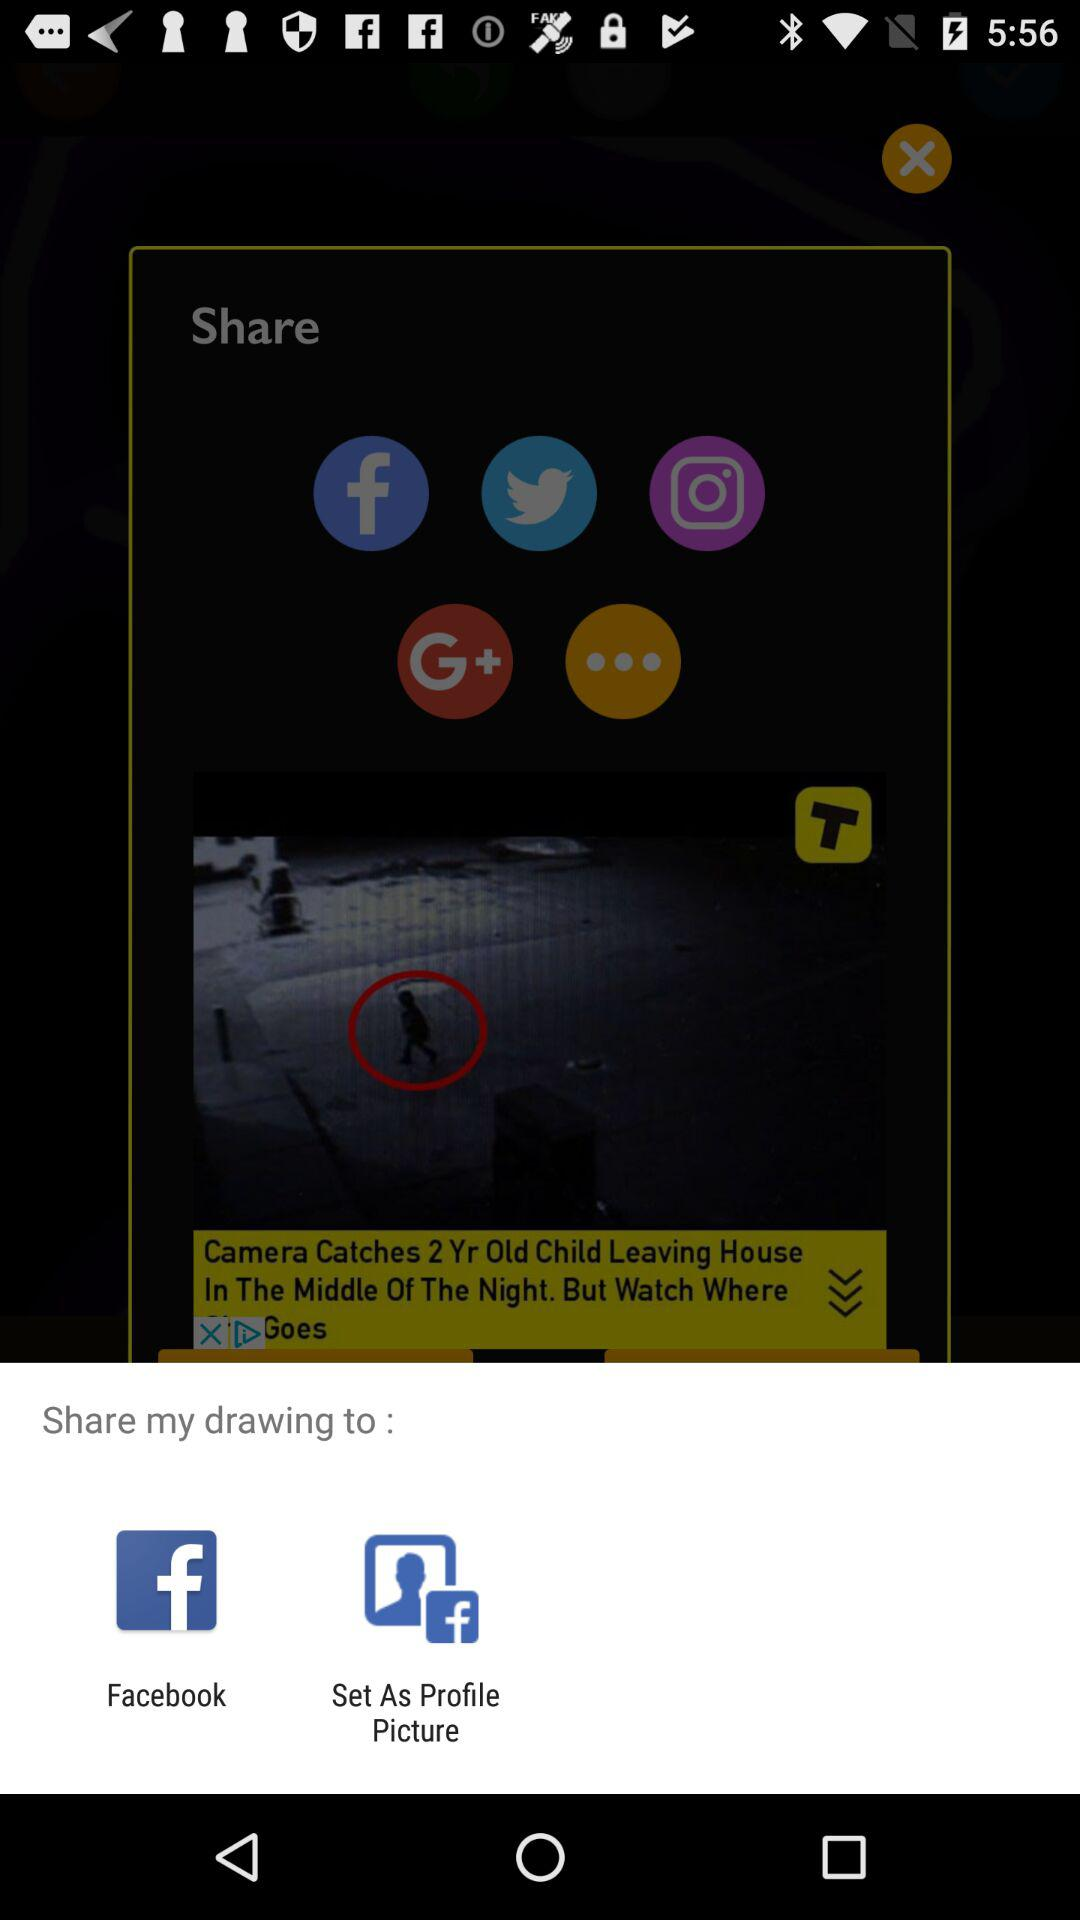Where can the drawing be shared? Drawing can be shared to "Facebook" and "Set As Profile Picture". 